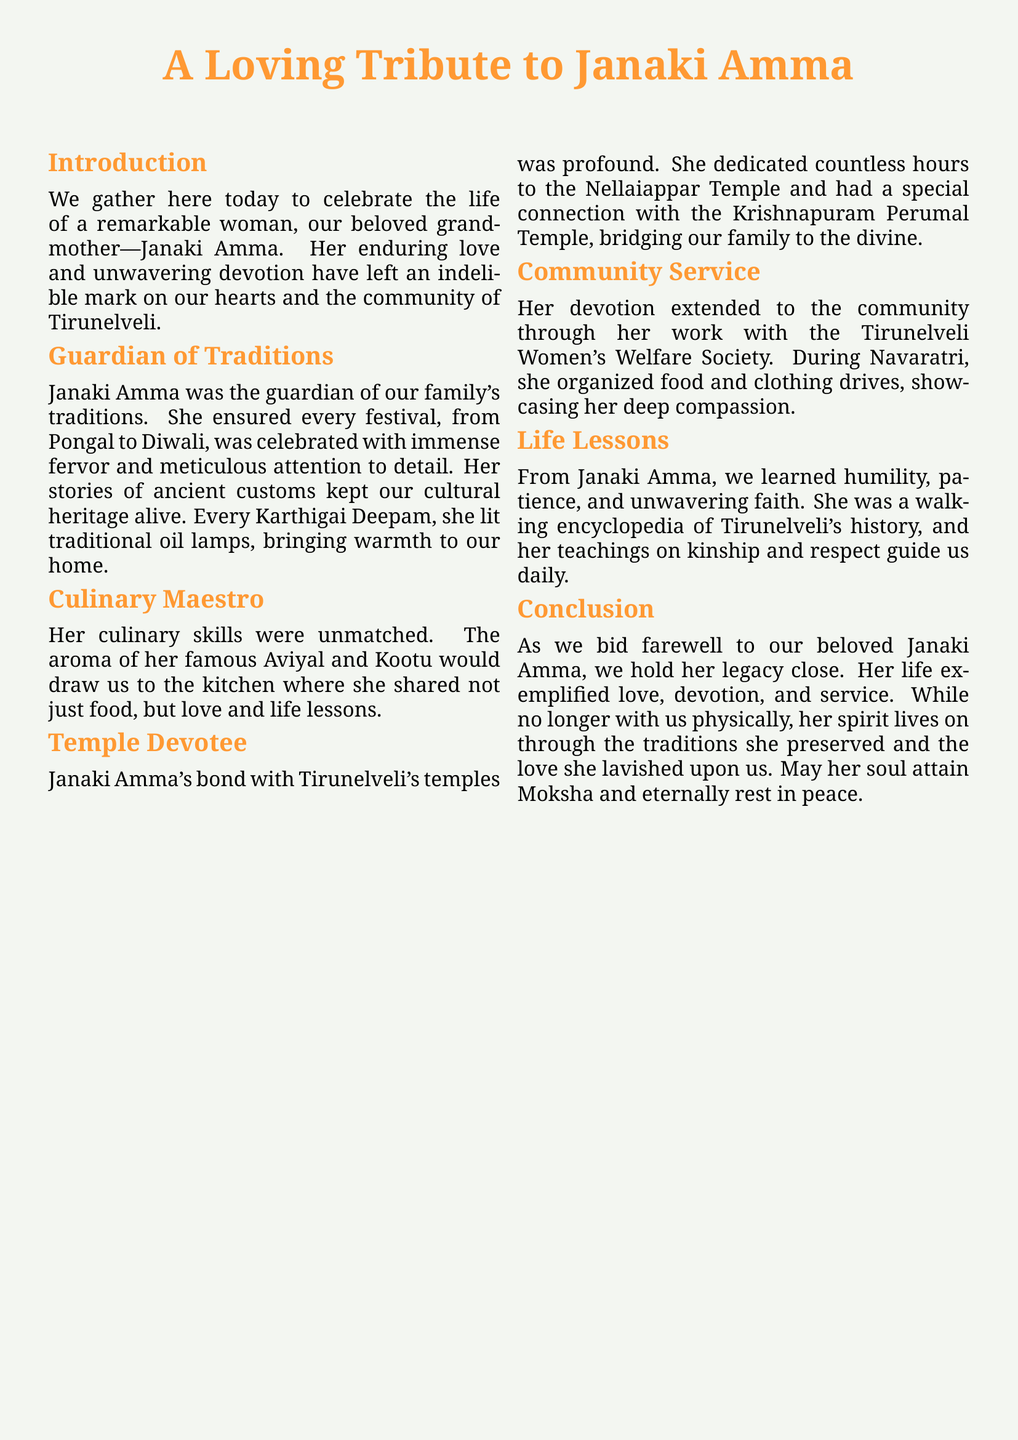What is the name of the grandmother being honored? The document specifically honors Janaki Amma as the beloved grandmother.
Answer: Janaki Amma What festival is mentioned that Janaki Amma celebrated? The document mentions Pongal and Diwali as festivals that Janaki Amma celebrated with fervor.
Answer: Pongal, Diwali Which temple is mentioned as having a special connection with Janaki Amma? The Krishnapuram Perumal Temple is noted to have a special connection with Janaki Amma.
Answer: Krishnapuram Perumal Temple What type of community work did Janaki Amma participate in? The document describes her involvement with food and clothing drives during Navaratri organized through the Tirunelveli Women's Welfare Society.
Answer: Community service What cuisine is Janaki Amma known for? The document highlights her unmatched culinary skills, especially her famous Aviyal and Kootu.
Answer: Aviyal, Kootu What significant life lesson did Janaki Amma teach? The document states that from Janaki Amma, the family learned humility, patience, and unwavering faith.
Answer: Humility, patience, faith How did Janaki Amma contribute to the preservation of culture? She kept the family's cultural heritage alive through stories of ancient customs and celebrating festivals.
Answer: Family traditions What legacy does Janaki Amma leave behind? The document posits that her legacy is exemplified through love, devotion, and service.
Answer: Love, devotion, service 